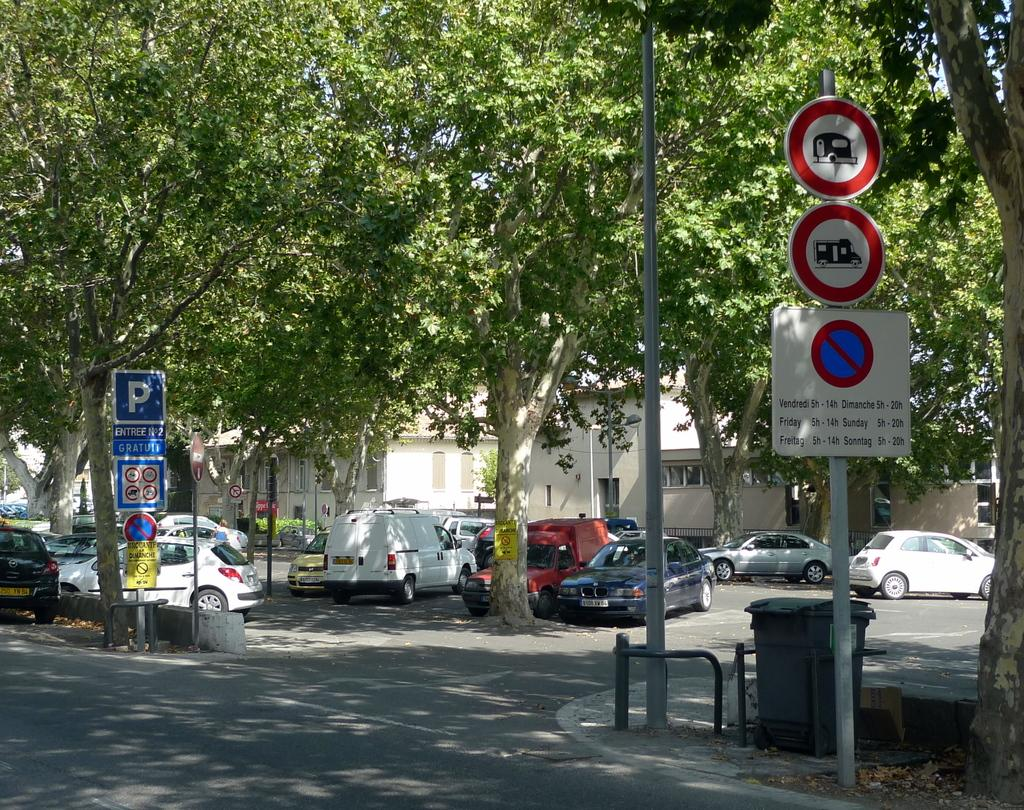Provide a one-sentence caption for the provided image. A bus schedule running 5-14 some days and 5-20 on others. 